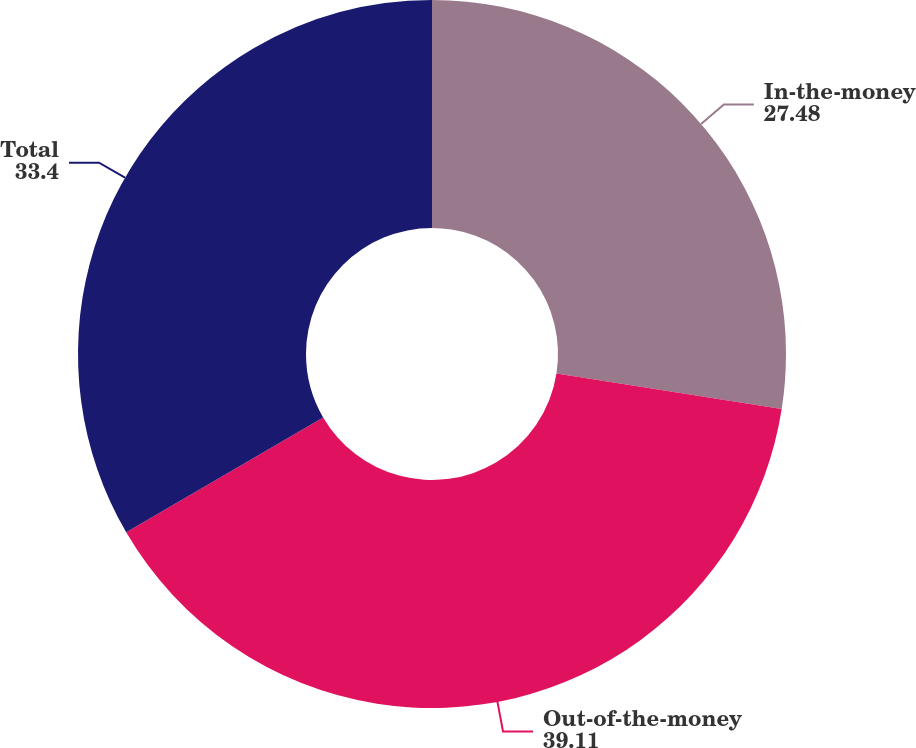Convert chart. <chart><loc_0><loc_0><loc_500><loc_500><pie_chart><fcel>In-the-money<fcel>Out-of-the-money<fcel>Total<nl><fcel>27.48%<fcel>39.11%<fcel>33.4%<nl></chart> 